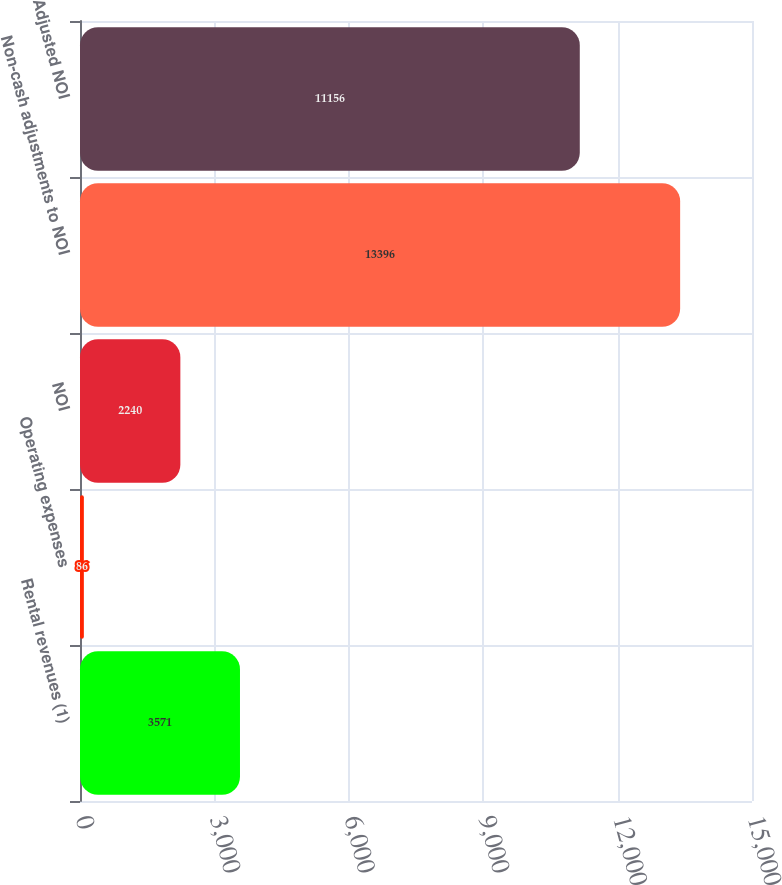Convert chart. <chart><loc_0><loc_0><loc_500><loc_500><bar_chart><fcel>Rental revenues (1)<fcel>Operating expenses<fcel>NOI<fcel>Non-cash adjustments to NOI<fcel>Adjusted NOI<nl><fcel>3571<fcel>86<fcel>2240<fcel>13396<fcel>11156<nl></chart> 